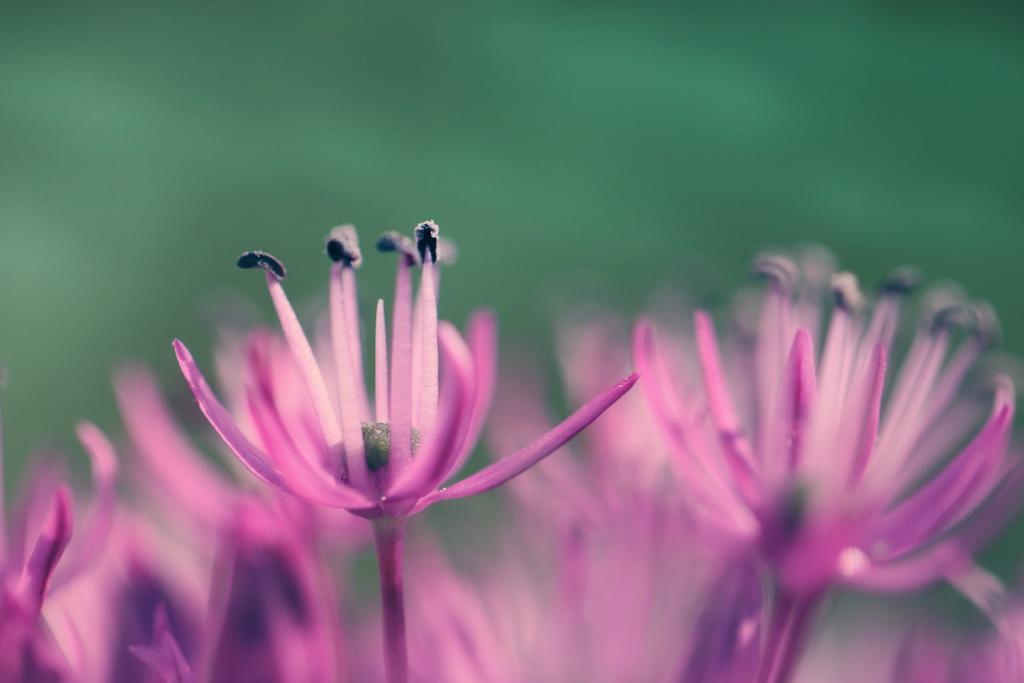How would you summarize this image in a sentence or two? In this image we can see some flowers which are in pink and black color. 